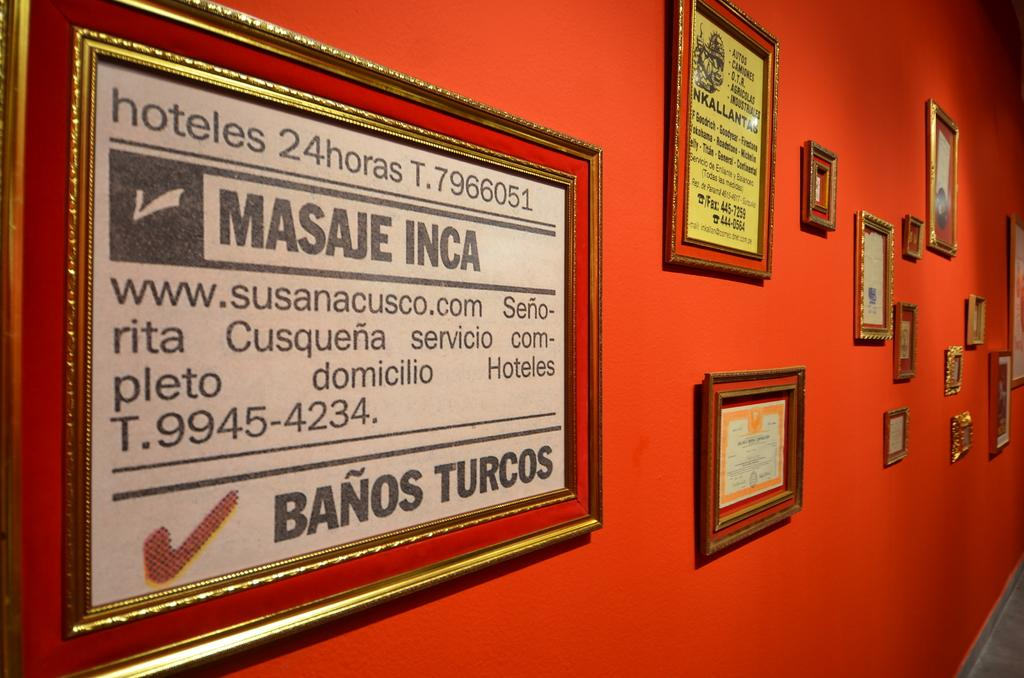<image>
Offer a succinct explanation of the picture presented. a photo album that says banos turcos on it 